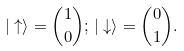<formula> <loc_0><loc_0><loc_500><loc_500>| \uparrow \rangle = { { 1 } \choose { 0 } } ; \, | \downarrow \rangle = { { 0 } \choose { 1 } } .</formula> 